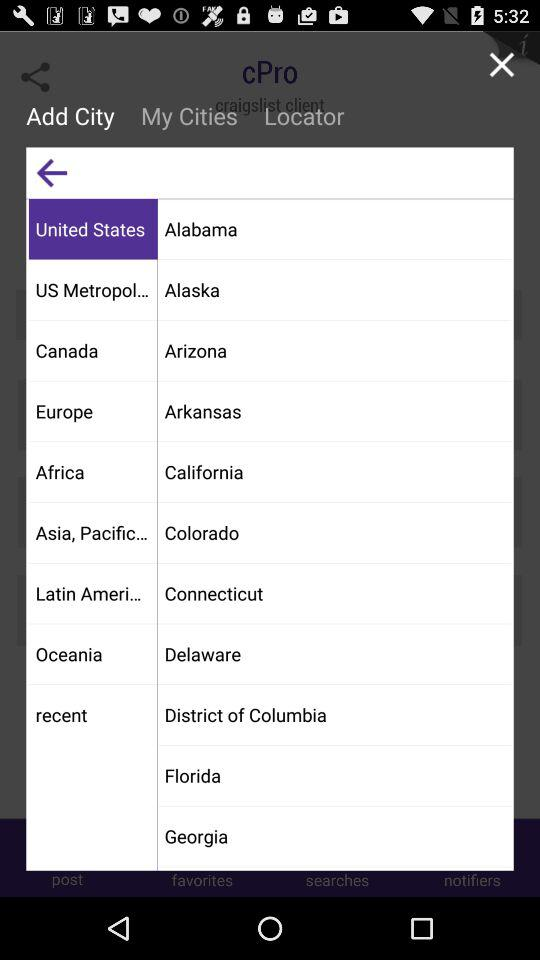Which is the selected item in the menu? The selected item is "United States". 